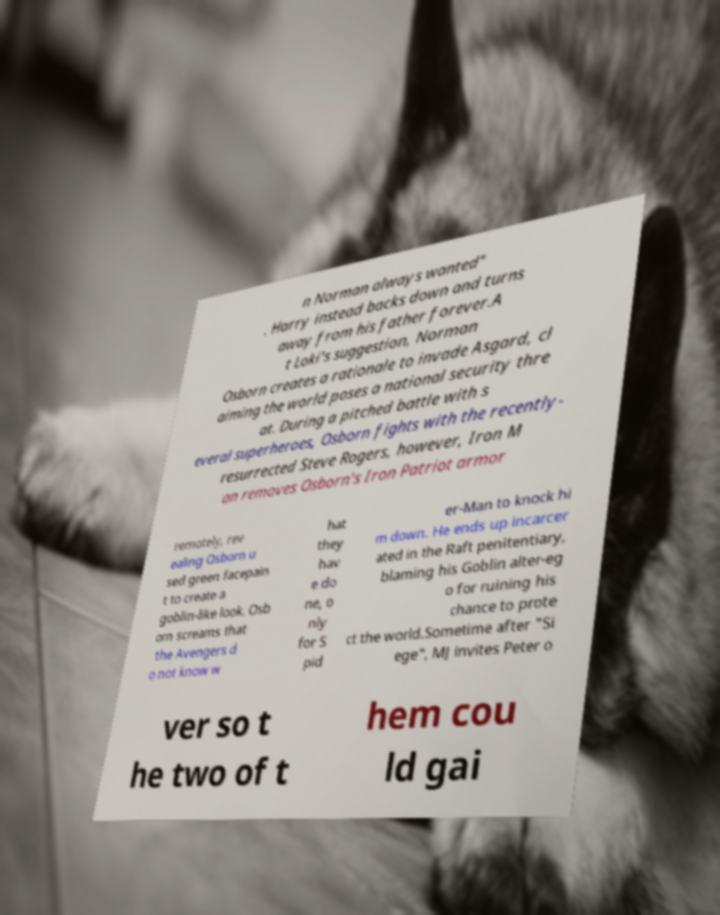Please read and relay the text visible in this image. What does it say? n Norman always wanted" . Harry instead backs down and turns away from his father forever.A t Loki's suggestion, Norman Osborn creates a rationale to invade Asgard, cl aiming the world poses a national security thre at. During a pitched battle with s everal superheroes, Osborn fights with the recently- resurrected Steve Rogers, however, Iron M an removes Osborn's Iron Patriot armor remotely, rev ealing Osborn u sed green facepain t to create a goblin-like look. Osb orn screams that the Avengers d o not know w hat they hav e do ne, o nly for S pid er-Man to knock hi m down. He ends up incarcer ated in the Raft penitentiary, blaming his Goblin alter-eg o for ruining his chance to prote ct the world.Sometime after "Si ege", MJ invites Peter o ver so t he two of t hem cou ld gai 